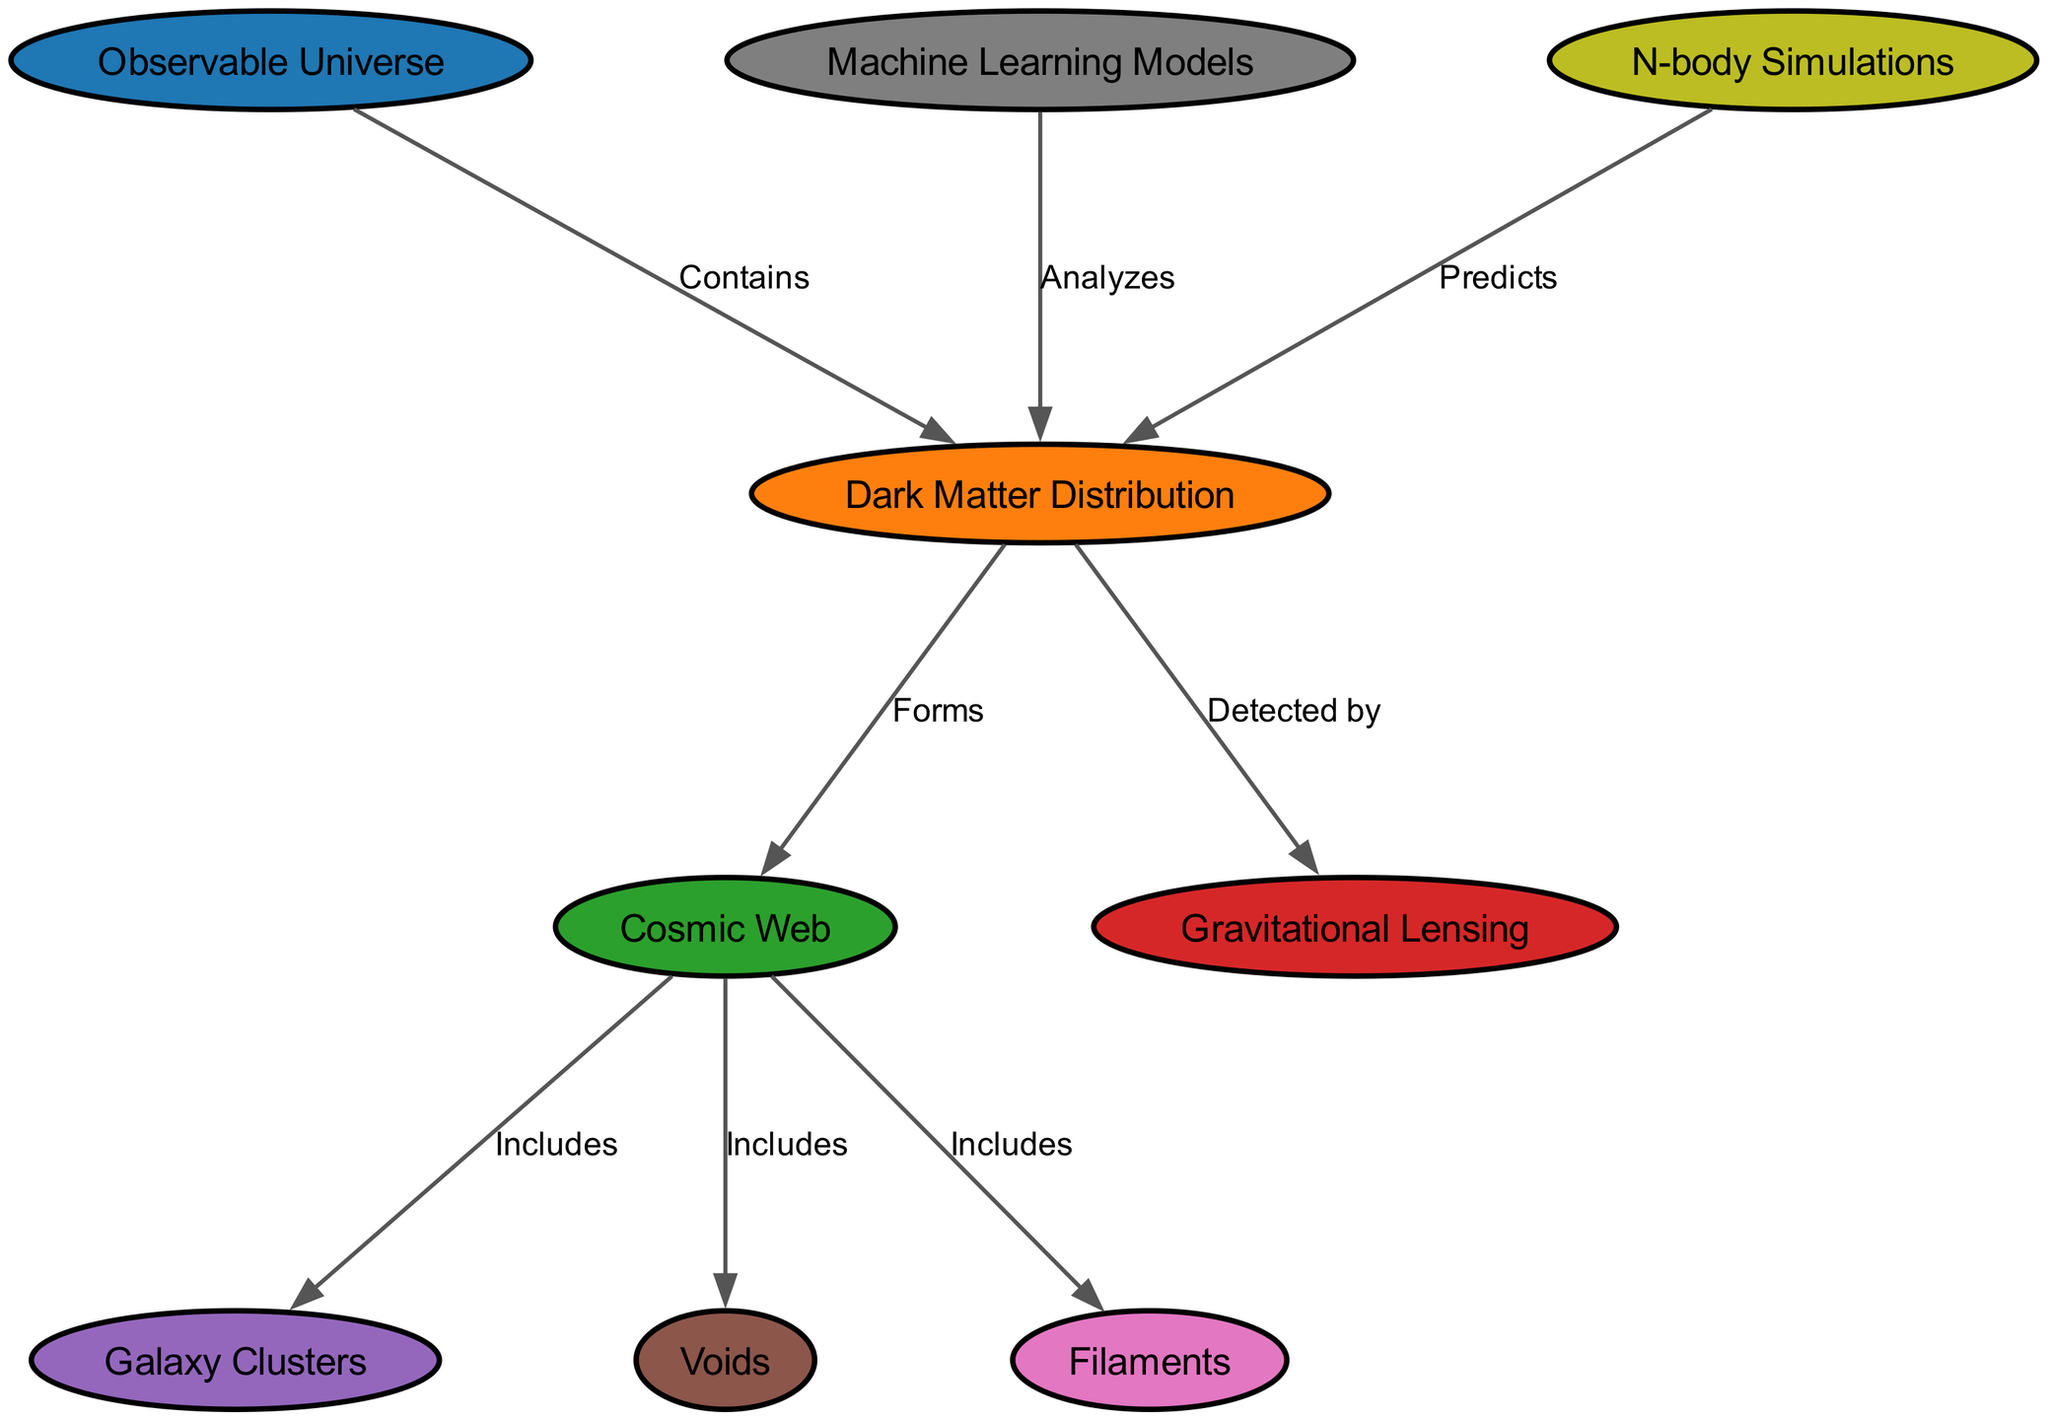What is the total number of nodes in the diagram? The diagram lists nodes for the "Observable Universe," "Dark Matter Distribution," "Cosmic Web," "Gravitational Lensing," "Galaxy Clusters," "Voids," "Filaments," "Machine Learning Models," and "N-body Simulations." Counting these nodes, there are a total of 9 nodes.
Answer: 9 Which node is detected by "Gravitational Lensing"? The diagram indicates that "Dark Matter Distribution" is detected by "Gravitational Lensing." Thus, the answer is derived directly from the edge labeled "Detected by" leading from "Dark Matter Distribution" to "Gravitational Lensing."
Answer: Dark Matter Distribution What relationships does "Cosmic Web" have? The "Cosmic Web" is connected to three nodes: "Galaxy Clusters," "Voids," and "Filaments." This is verified by the edges labeled "Includes," which show that "Cosmic Web" encompasses these three elements in the structure of the diagram.
Answer: Galaxy Clusters, Voids, Filaments How many edges are in the diagram? The diagram shows connections between various nodes through edges. Counting these connections, there are a total of 8 edges that illustrate the relationships between the nodes present in the diagram.
Answer: 8 What can "Machine Learning Models" be used for in this diagram? "Machine Learning Models" in the diagram is used to analyze "Dark Matter Distribution," as indicated by the edge labeled "Analyzes" that connects these two nodes. This relationship shows the function or purpose of the "Machine Learning Models" in understanding the distribution of dark matter.
Answer: Analyzes Which node forms the "Cosmic Web"? According to the diagram, the "Dark Matter Distribution" is identified as forming the "Cosmic Web." This relationship is explicitly stated by the edge labeled "Forms" leading from "Dark Matter Distribution" to "Cosmic Web."
Answer: Dark Matter Distribution What type of simulations predict "Dark Matter Distribution"? The diagram illustrates that "N-body Simulations" are used to predict "Dark Matter Distribution." This is shown by the edge labeled "Predicts," which connects "N-body Simulations" to "Dark Matter Distribution."
Answer: N-body Simulations What is the main component of the "Observable Universe"? The diagram points out that "Dark Matter Distribution" is a key component of the "Observable Universe," indicated by the edge labeled "Contains," which directly links these two entities.
Answer: Dark Matter Distribution 